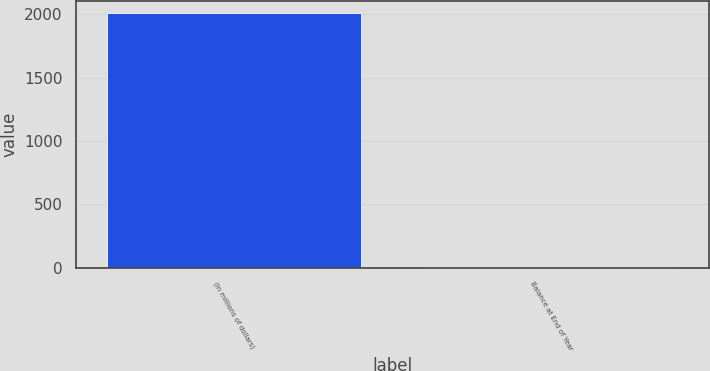<chart> <loc_0><loc_0><loc_500><loc_500><bar_chart><fcel>(in millions of dollars)<fcel>Balance at End of Year<nl><fcel>2009<fcel>3.2<nl></chart> 